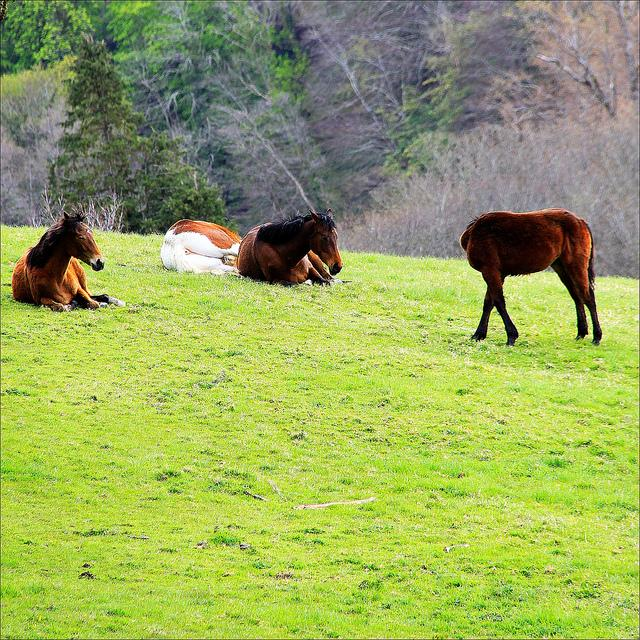Which of these horses would stand out in a dark setting?

Choices:
A) far left
B) second right
C) second left
D) far right second left 